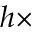Convert formula to latex. <formula><loc_0><loc_0><loc_500><loc_500>h \times</formula> 